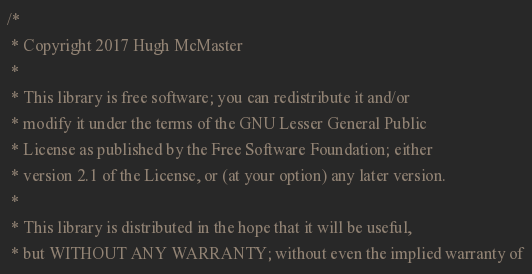Convert code to text. <code><loc_0><loc_0><loc_500><loc_500><_C_>/*
 * Copyright 2017 Hugh McMaster
 *
 * This library is free software; you can redistribute it and/or
 * modify it under the terms of the GNU Lesser General Public
 * License as published by the Free Software Foundation; either
 * version 2.1 of the License, or (at your option) any later version.
 *
 * This library is distributed in the hope that it will be useful,
 * but WITHOUT ANY WARRANTY; without even the implied warranty of</code> 